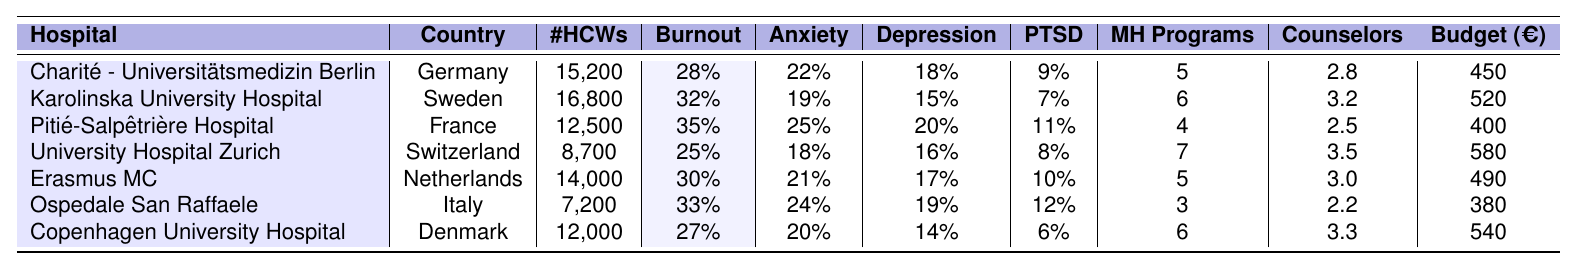What is the reported burnout rate at Pitié-Salpêtrière Hospital? The reported burnout rate at Pitié-Salpêtrière Hospital is given in the table as 35%.
Answer: 35% Which hospital has the highest reported rate of anxiety prevalence? By comparing the anxiety prevalence rates, Pitié-Salpêtrière Hospital has the highest rate at 25%.
Answer: Pitié-Salpêtrière Hospital How many healthcare workers are at University Hospital Zurich? The table shows that University Hospital Zurich has 8,700 healthcare workers.
Answer: 8,700 What is the average annual mental health budget per worker for the hospitals listed? To find the average, add up the budgets (450 + 520 + 400 + 580 + 490 + 380 + 540) = 3860. There are 7 hospitals, so 3860/7 ≈ 550.
Answer: 550 Which hospital has the most mental health support programs? The hospital with the most mental health support programs is University Hospital Zurich with 7 programs.
Answer: University Hospital Zurich Does Ospedale San Raffaele have a lower reported burnout rate than University Hospital Zurich? Ospedale San Raffaele has a reported burnout rate of 33%, while University Hospital Zurich has a rate of 25%. Therefore, Ospedale San Raffaele does not have a lower burnout rate.
Answer: No What is the difference in PTSD prevalence between Erasmus MC and Charité - Universitätsmedizin Berlin? Erasmus MC has a PTSD prevalence of 10% and Charité - Universitätsmedizin Berlin has a rate of 9%. The difference is 10% - 9% = 1%.
Answer: 1% How many staff counselors per 1,000 workers does Copenhagen University Hospital have compared to Karolinska University Hospital? Copenhagen University Hospital has 3.3 staff counselors per 1,000 workers, while Karolinska University Hospital has 3.2. The difference is 3.3 - 3.2 = 0.1.
Answer: 0.1 What is the relationship between the number of healthcare workers and the reported burnout rate? To analyze the correlation, we observe that larger hospitals like Pitié-Salpêtrière Hospital (12,500 workers) and Ospedale San Raffaele (7,200 workers) exhibit higher burnout rates, while University Hospital Zurich (8,700) has a lower rate. This suggests a complex relationship where larger facilities may not always correlate with higher burnout, emphasizing that other factors could influence burnout rates.
Answer: Complex relationship Is the annual mental health budget per worker at Ospedale San Raffaele less than that of Erasmus MC? Ospedale San Raffaele has a budget of 380 EUR, while Erasmus MC has a budget of 490 EUR. Thus, Ospedale San Raffaele's budget is less.
Answer: Yes 